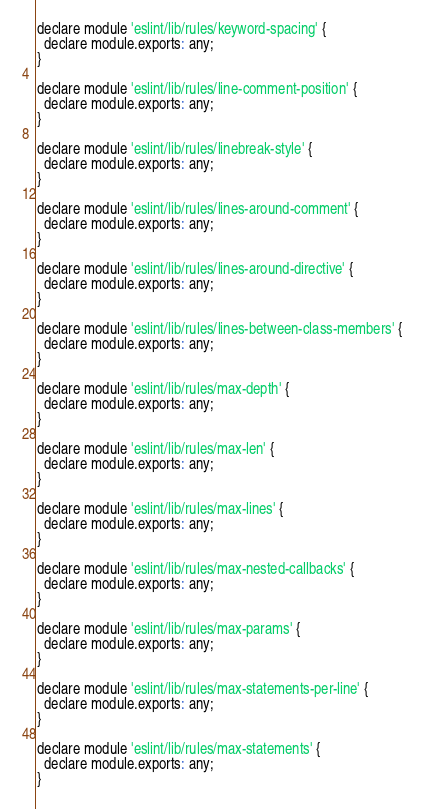<code> <loc_0><loc_0><loc_500><loc_500><_JavaScript_>declare module 'eslint/lib/rules/keyword-spacing' {
  declare module.exports: any;
}

declare module 'eslint/lib/rules/line-comment-position' {
  declare module.exports: any;
}

declare module 'eslint/lib/rules/linebreak-style' {
  declare module.exports: any;
}

declare module 'eslint/lib/rules/lines-around-comment' {
  declare module.exports: any;
}

declare module 'eslint/lib/rules/lines-around-directive' {
  declare module.exports: any;
}

declare module 'eslint/lib/rules/lines-between-class-members' {
  declare module.exports: any;
}

declare module 'eslint/lib/rules/max-depth' {
  declare module.exports: any;
}

declare module 'eslint/lib/rules/max-len' {
  declare module.exports: any;
}

declare module 'eslint/lib/rules/max-lines' {
  declare module.exports: any;
}

declare module 'eslint/lib/rules/max-nested-callbacks' {
  declare module.exports: any;
}

declare module 'eslint/lib/rules/max-params' {
  declare module.exports: any;
}

declare module 'eslint/lib/rules/max-statements-per-line' {
  declare module.exports: any;
}

declare module 'eslint/lib/rules/max-statements' {
  declare module.exports: any;
}
</code> 